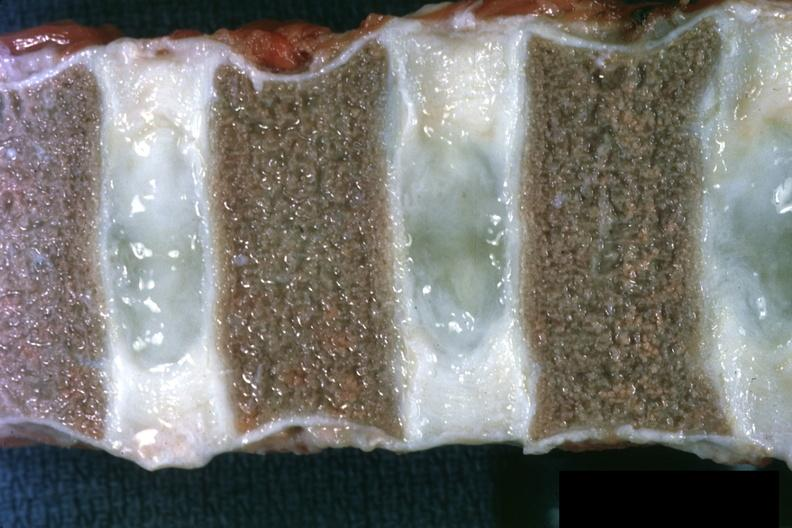what is present?
Answer the question using a single word or phrase. Hematologic 